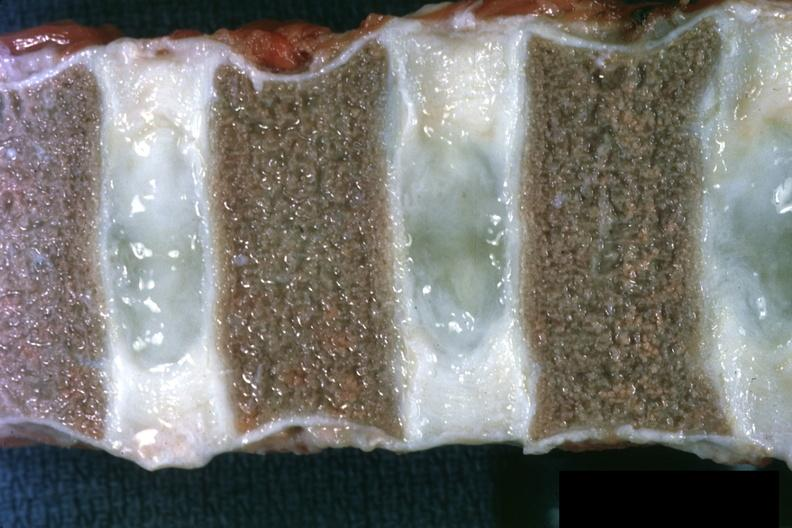what is present?
Answer the question using a single word or phrase. Hematologic 